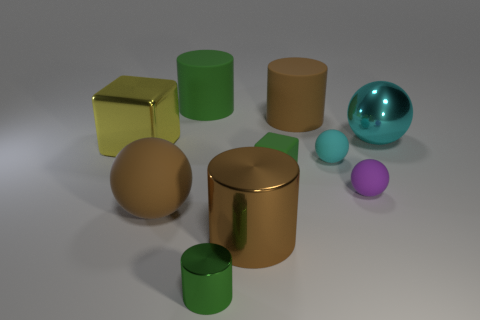Are there an equal number of large yellow cubes that are to the left of the big shiny block and tiny green shiny spheres?
Ensure brevity in your answer.  Yes. How many objects are the same material as the small green cube?
Give a very brief answer. 5. What is the color of the tiny cube that is made of the same material as the small cyan object?
Give a very brief answer. Green. Do the purple object and the cyan rubber thing have the same shape?
Give a very brief answer. Yes. There is a matte thing that is behind the rubber cylinder that is to the right of the small green shiny cylinder; is there a matte thing that is in front of it?
Keep it short and to the point. Yes. How many spheres have the same color as the large metallic cylinder?
Your response must be concise. 1. What is the shape of the brown metal thing that is the same size as the cyan metal object?
Make the answer very short. Cylinder. There is a large cyan thing; are there any cyan metal objects on the left side of it?
Your response must be concise. No. Do the matte cube and the purple sphere have the same size?
Ensure brevity in your answer.  Yes. The brown rubber object on the left side of the tiny cylinder has what shape?
Your response must be concise. Sphere. 